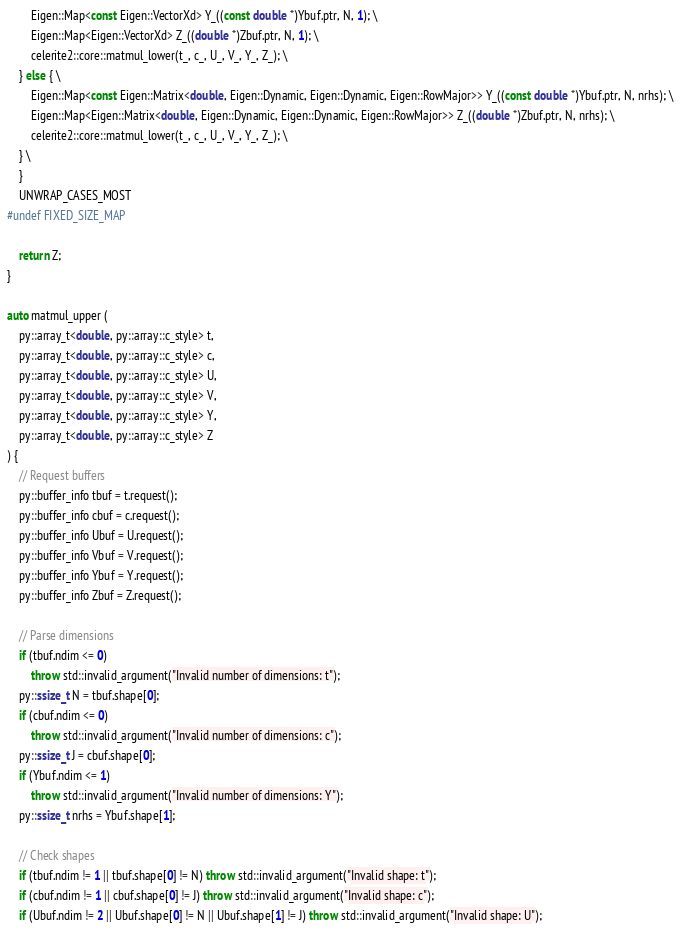Convert code to text. <code><loc_0><loc_0><loc_500><loc_500><_C++_>        Eigen::Map<const Eigen::VectorXd> Y_((const double *)Ybuf.ptr, N, 1); \
        Eigen::Map<Eigen::VectorXd> Z_((double *)Zbuf.ptr, N, 1); \
        celerite2::core::matmul_lower(t_, c_, U_, V_, Y_, Z_); \
    } else { \
        Eigen::Map<const Eigen::Matrix<double, Eigen::Dynamic, Eigen::Dynamic, Eigen::RowMajor>> Y_((const double *)Ybuf.ptr, N, nrhs); \
        Eigen::Map<Eigen::Matrix<double, Eigen::Dynamic, Eigen::Dynamic, Eigen::RowMajor>> Z_((double *)Zbuf.ptr, N, nrhs); \
        celerite2::core::matmul_lower(t_, c_, U_, V_, Y_, Z_); \
    } \
    }
    UNWRAP_CASES_MOST
#undef FIXED_SIZE_MAP

    return Z;
}

auto matmul_upper (
    py::array_t<double, py::array::c_style> t,
    py::array_t<double, py::array::c_style> c,
    py::array_t<double, py::array::c_style> U,
    py::array_t<double, py::array::c_style> V,
    py::array_t<double, py::array::c_style> Y,
    py::array_t<double, py::array::c_style> Z
) {
    // Request buffers
    py::buffer_info tbuf = t.request();
    py::buffer_info cbuf = c.request();
    py::buffer_info Ubuf = U.request();
    py::buffer_info Vbuf = V.request();
    py::buffer_info Ybuf = Y.request();
    py::buffer_info Zbuf = Z.request();

    // Parse dimensions
    if (tbuf.ndim <= 0)
        throw std::invalid_argument("Invalid number of dimensions: t");
    py::ssize_t N = tbuf.shape[0];
    if (cbuf.ndim <= 0)
        throw std::invalid_argument("Invalid number of dimensions: c");
    py::ssize_t J = cbuf.shape[0];
    if (Ybuf.ndim <= 1)
        throw std::invalid_argument("Invalid number of dimensions: Y");
    py::ssize_t nrhs = Ybuf.shape[1];

    // Check shapes
    if (tbuf.ndim != 1 || tbuf.shape[0] != N) throw std::invalid_argument("Invalid shape: t");
    if (cbuf.ndim != 1 || cbuf.shape[0] != J) throw std::invalid_argument("Invalid shape: c");
    if (Ubuf.ndim != 2 || Ubuf.shape[0] != N || Ubuf.shape[1] != J) throw std::invalid_argument("Invalid shape: U");</code> 